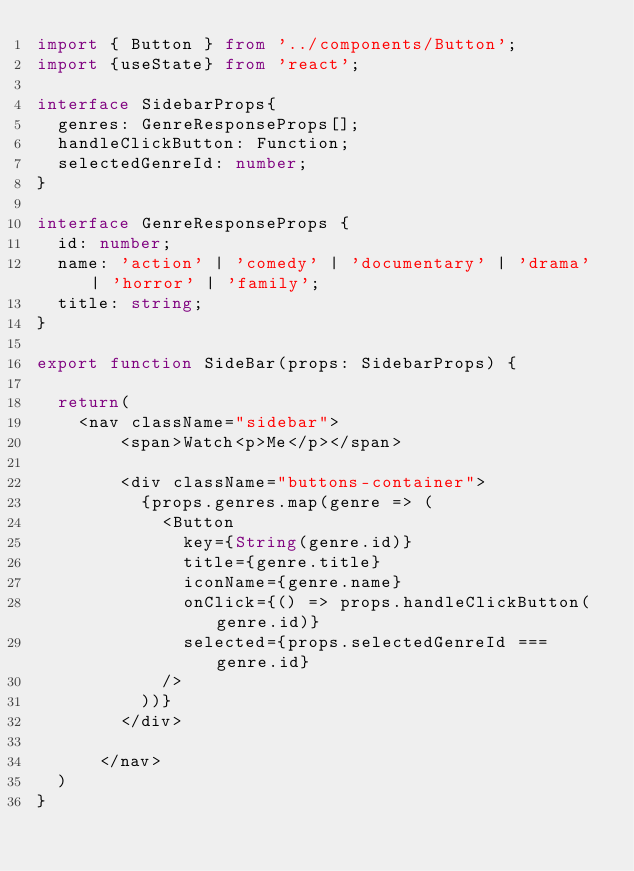<code> <loc_0><loc_0><loc_500><loc_500><_TypeScript_>import { Button } from '../components/Button';
import {useState} from 'react';

interface SidebarProps{
  genres: GenreResponseProps[];
  handleClickButton: Function;
  selectedGenreId: number;
}

interface GenreResponseProps {
  id: number;
  name: 'action' | 'comedy' | 'documentary' | 'drama' | 'horror' | 'family';
  title: string;
}

export function SideBar(props: SidebarProps) {

  return(
    <nav className="sidebar">
        <span>Watch<p>Me</p></span>

        <div className="buttons-container">
          {props.genres.map(genre => (
            <Button
              key={String(genre.id)}
              title={genre.title}
              iconName={genre.name}
              onClick={() => props.handleClickButton(genre.id)}
              selected={props.selectedGenreId === genre.id}
            />
          ))}
        </div>

      </nav>
  )
}</code> 